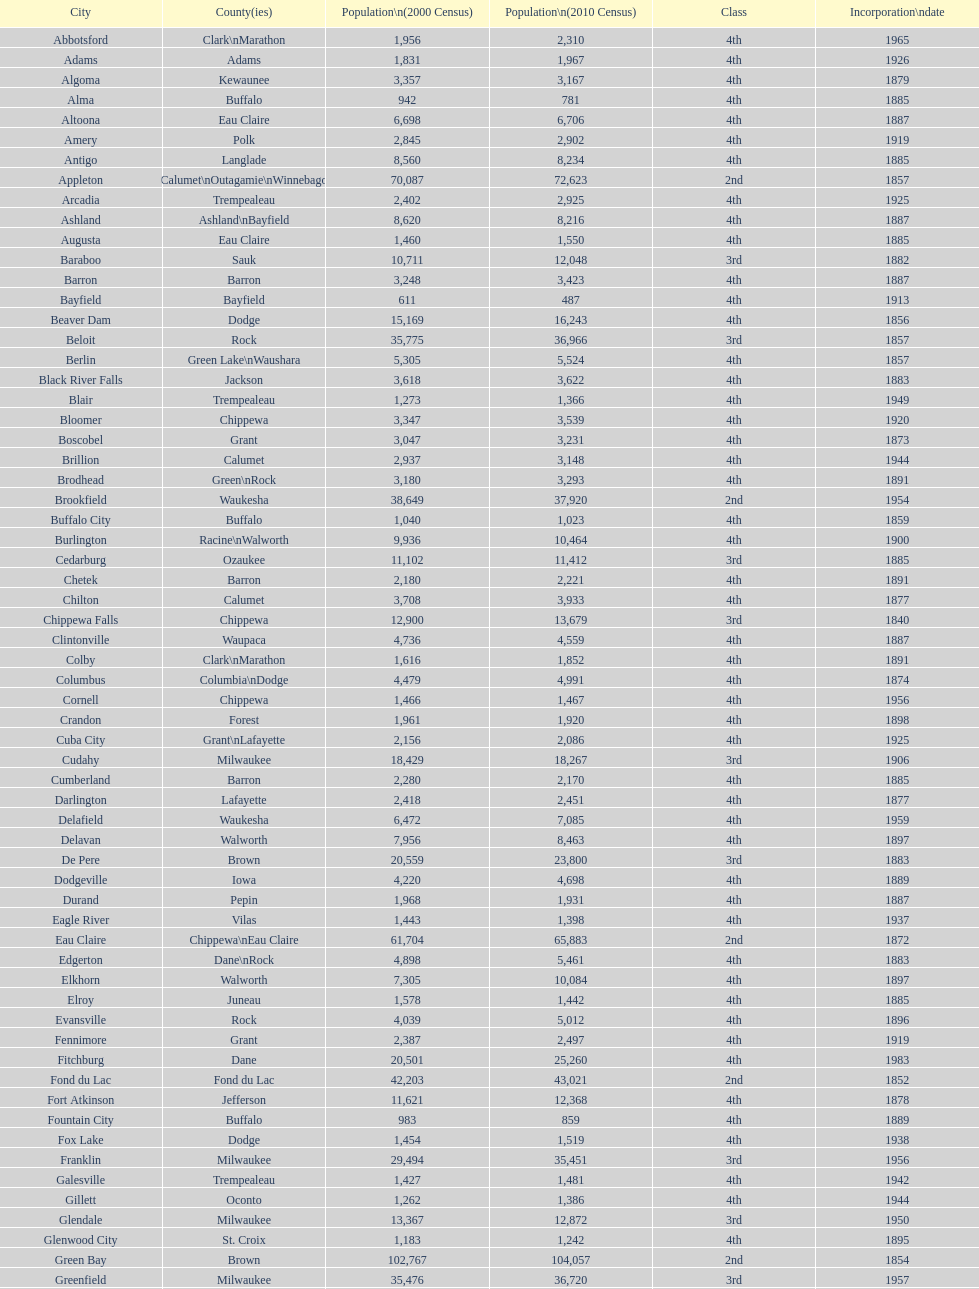How many cities are in wisconsin? 190. 